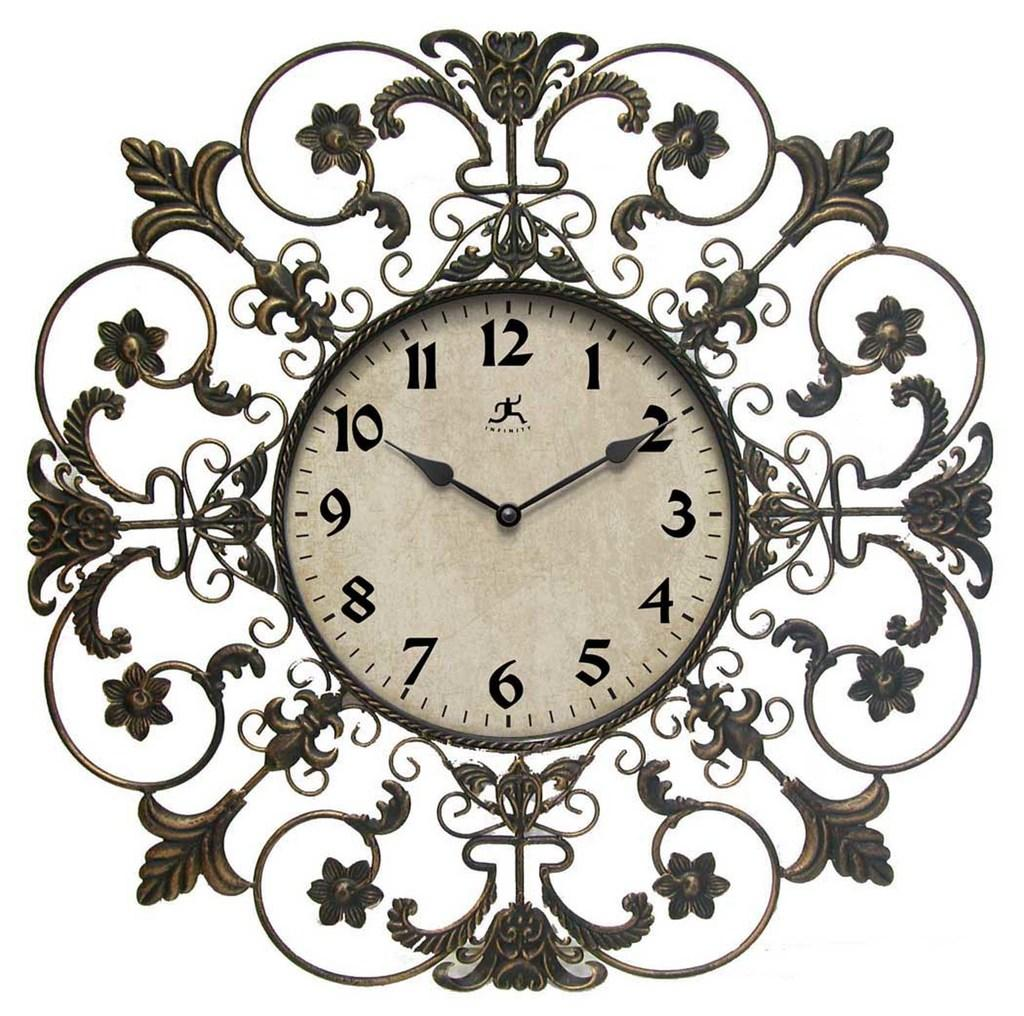<image>
Describe the image concisely. Clock showing the hands on the number 10 and 2. 